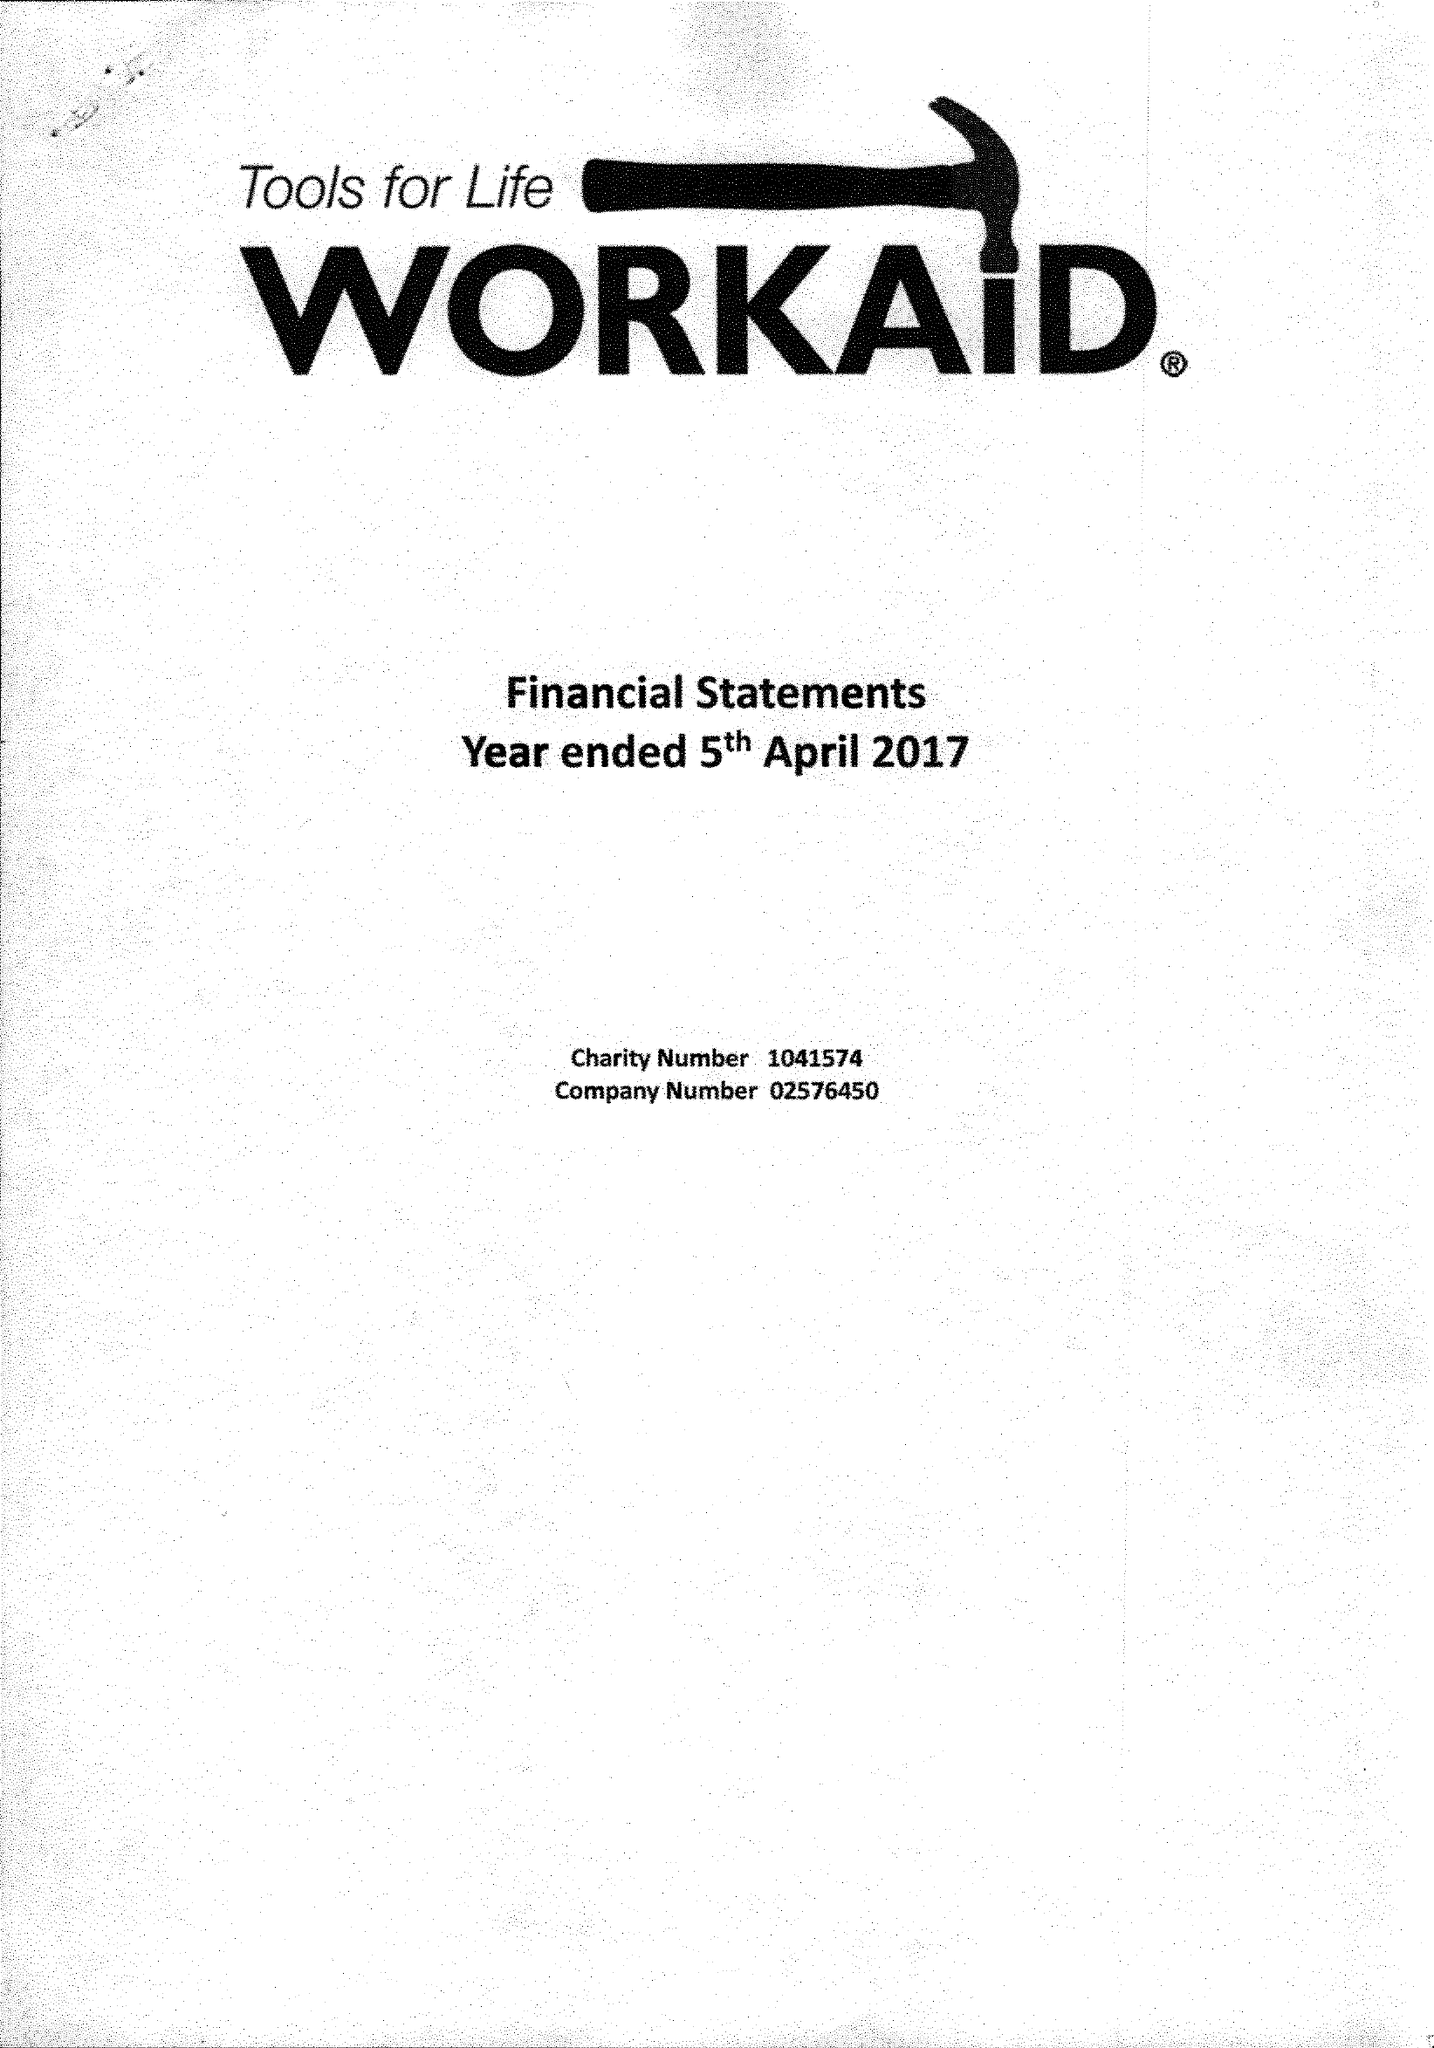What is the value for the address__post_town?
Answer the question using a single word or phrase. CHESHAM 